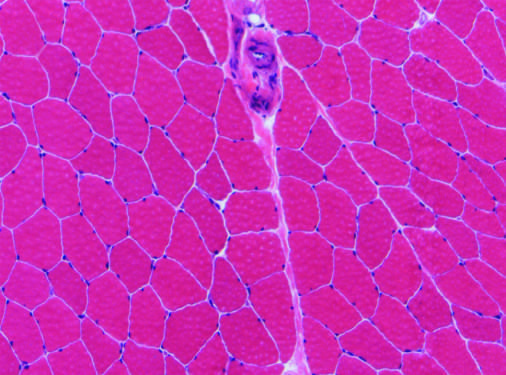what is present (top center)?
Answer the question using a single word or phrase. A perimysial interfascicular septum containing a blood vessel 